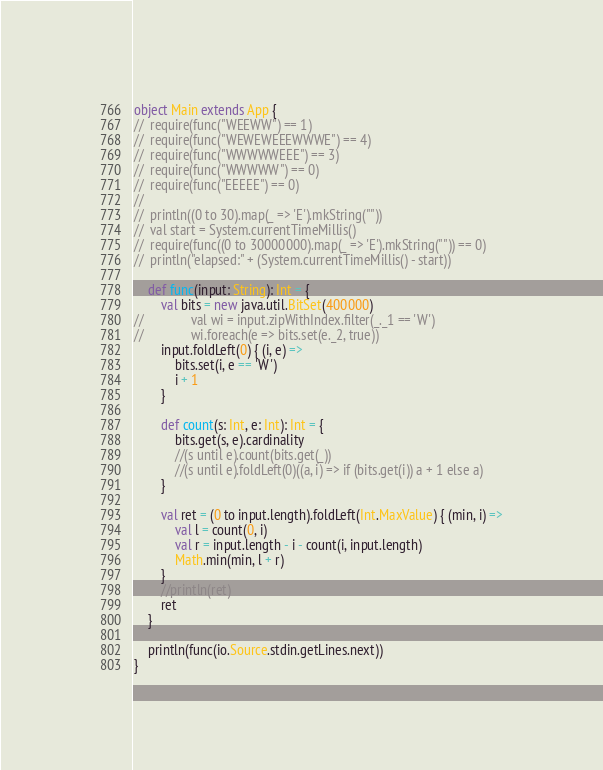<code> <loc_0><loc_0><loc_500><loc_500><_Scala_>object Main extends App {
//	require(func("WEEWW") == 1)
//	require(func("WEWEWEEEWWWE") == 4)
//	require(func("WWWWWEEE") == 3)
//	require(func("WWWWW") == 0)
//	require(func("EEEEE") == 0)
//
//	println((0 to 30).map(_ => 'E').mkString(""))
//	val start = System.currentTimeMillis()
//	require(func((0 to 30000000).map(_ => 'E').mkString("")) == 0)
//	println("elapsed:" + (System.currentTimeMillis() - start))

	def func(input: String): Int = {
		val bits = new java.util.BitSet(400000)
//				val wi = input.zipWithIndex.filter(_._1 == 'W')
//				wi.foreach(e => bits.set(e._2, true))
		input.foldLeft(0) { (i, e) =>
			bits.set(i, e == 'W')
			i + 1
		}

		def count(s: Int, e: Int): Int = {
			bits.get(s, e).cardinality
			//(s until e).count(bits.get(_))
			//(s until e).foldLeft(0)((a, i) => if (bits.get(i)) a + 1 else a)
		}

		val ret = (0 to input.length).foldLeft(Int.MaxValue) { (min, i) =>
			val l = count(0, i)
			val r = input.length - i - count(i, input.length)
			Math.min(min, l + r)
		}
		//println(ret)
		ret
	}

	println(func(io.Source.stdin.getLines.next))
}</code> 